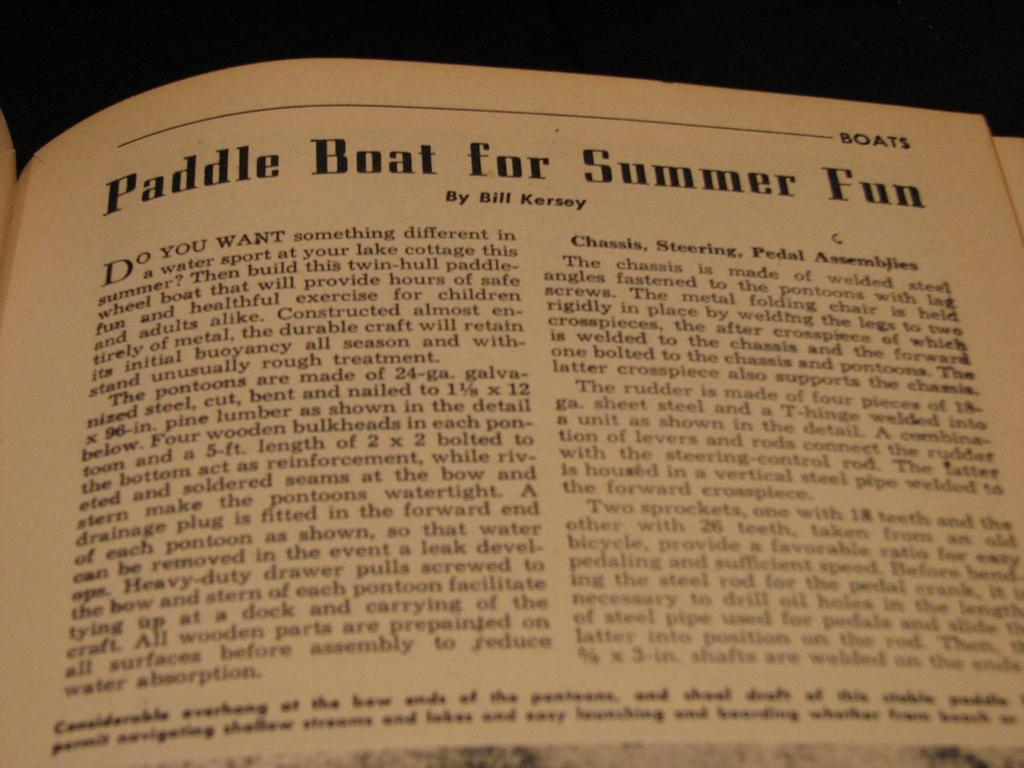Provide a one-sentence caption for the provided image. A book with the title Paddle Boat for Summer Fun. 